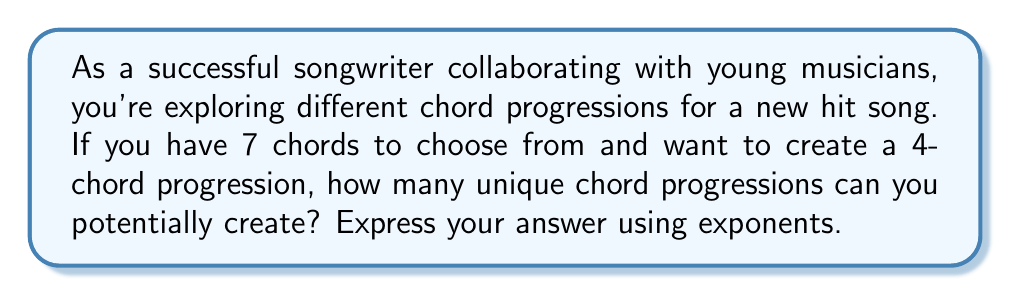What is the answer to this math problem? To solve this problem, we need to understand the concept of permutations with repetition. In this case:

1. We have 7 chords to choose from for each position in the progression.
2. We are selecting 4 chords in total for the progression.
3. We can repeat chords (i.e., use the same chord more than once in the progression).

The formula for permutations with repetition is:

$$ n^r $$

Where:
$n$ = number of options for each selection
$r$ = number of selections made

In our case:
$n = 7$ (7 chords to choose from)
$r = 4$ (4-chord progression)

Therefore, the number of possible chord progressions is:

$$ 7^4 $$

To calculate this:

$$ 7^4 = 7 \times 7 \times 7 \times 7 = 2,401 $$

This means there are 2,401 unique 4-chord progressions possible using 7 chords.
Answer: $7^4 = 2,401$ possible chord progressions 